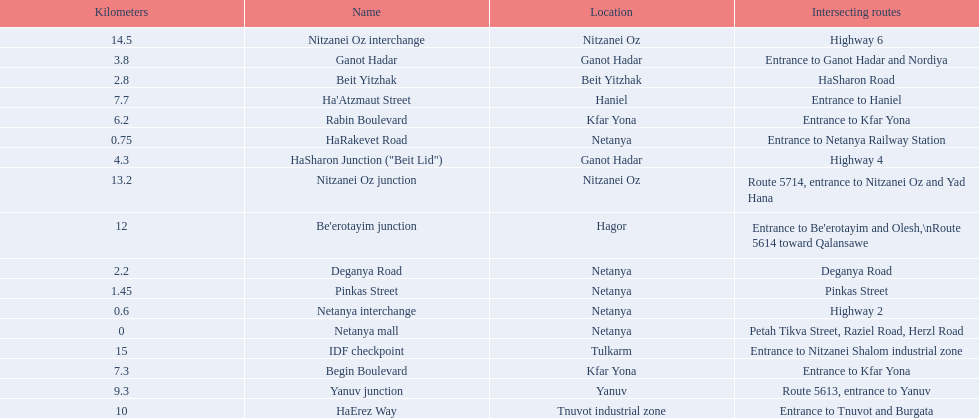How many sections intersect highway 2? 1. 